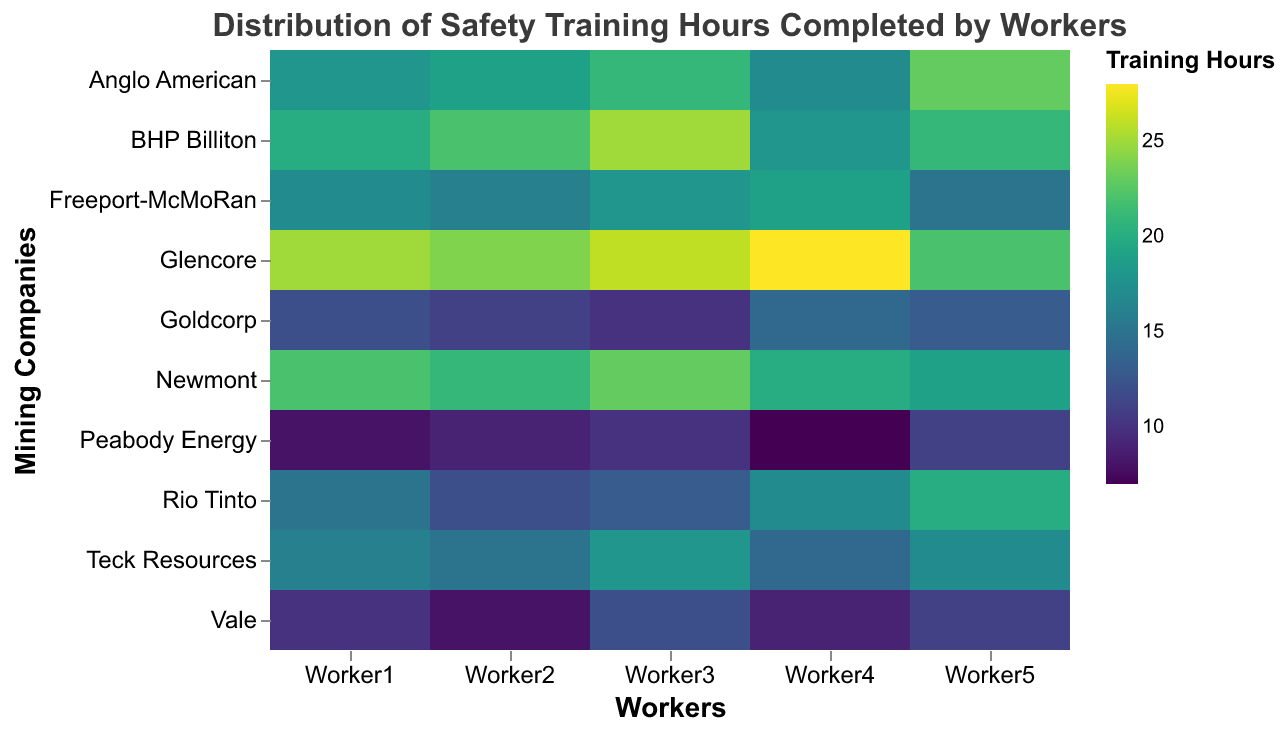What's the title of the figure? The title of the figure is clearly stated at the top and reads "Distribution of Safety Training Hours Completed by Workers".
Answer: Distribution of Safety Training Hours Completed by Workers Which mining company has the highest total training hours for all workers? To find the company with the highest total training hours, sum the training hours for each worker in each company and compare. Summing up the hours for Glencore, we get (25 + 24 + 26 + 28 + 22) = 125, which is the highest total.
Answer: Glencore How many companies have at least one worker completing more than 20 hours of training? By inspecting the heatmap, count the companies with any color cell indicating more than 20 hours. These companies are BHP Billiton, Anglo American, Glencore, Newmont, and Freeport-McMoRan.
Answer: 5 Which worker from Teck Resources completed the fewest training hours? On the heatmap, locate the Teck Resources row and identify the cell with the lightest color, which corresponds to the lowest value. Worker2 has the fewest hours, completing 15.
Answer: Worker2 Compare the average training hours between workers from Rio Tinto and Anglo American. Calculate the average for each company. Rio Tinto: (15 + 12 + 13 + 17 + 20)/5 = 15.4. Anglo American: (18 + 19 + 21 + 17 + 23)/5 = 19.6. Comparing these, Anglo American has higher average training hours.
Answer: Anglo American Which company has the most variation in training hours among its workers? Assess the difference between the highest and lowest training hours for each company. Vale's variation is the highest, with the smallest value of 8 and the largest value of 12, giving a difference of 4.
Answer: Vale Determine the worker with the highest training hours across all companies. Identify the cell with the darkest color on the heatmap. The darkest cell is Worker4 from Glencore with 28 hours.
Answer: Worker4 from Glencore Find the median training hours for all workers at Peabody Energy. Order the training hours (7, 8, 9, 10, 11). The middle value (the median) is 9.
Answer: 9 Which two companies have the closest average training hours for their workers? Calculate average training hours for each company and compare to find the closest pair. Rio Tinto: 15.4, BHP Billiton: 21.2, Vale: 10, Anglo American: 19.6, Glencore: 25, Freeport-McMoRan: 17, Goldcorp: 12, Newmont: 21, Teck Resources: 16, Peabody Energy: 9. The closest averages are BHP Billiton (21.2) and Newmont (21).
Answer: BHP Billiton and Newmont Identify which worker from Goldcorp completed equal or fewer training hours than the least trained worker from Newmont. The least trained worker from Newmont completed 19 hours. At Goldcorp, Workers 1, 2, 3, 4, and 5 completed 12, 11, 10, 14, and 13 hours respectively, all of which are fewer.
Answer: Workers 1, 2, 3, 4, 5 from Goldcorp 